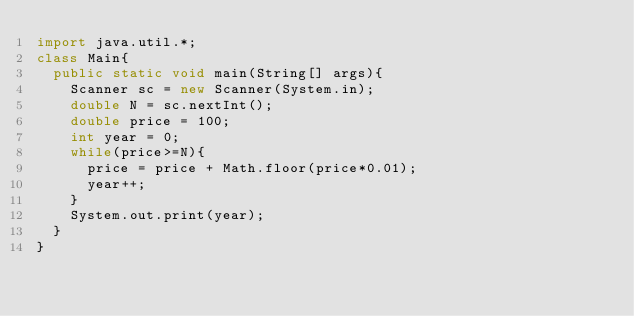Convert code to text. <code><loc_0><loc_0><loc_500><loc_500><_Java_>import java.util.*;
class Main{
  public static void main(String[] args){
    Scanner sc = new Scanner(System.in);
    double N = sc.nextInt();
    double price = 100;
    int year = 0;
    while(price>=N){
      price = price + Math.floor(price*0.01);
      year++;
    }
    System.out.print(year);
  }
}</code> 